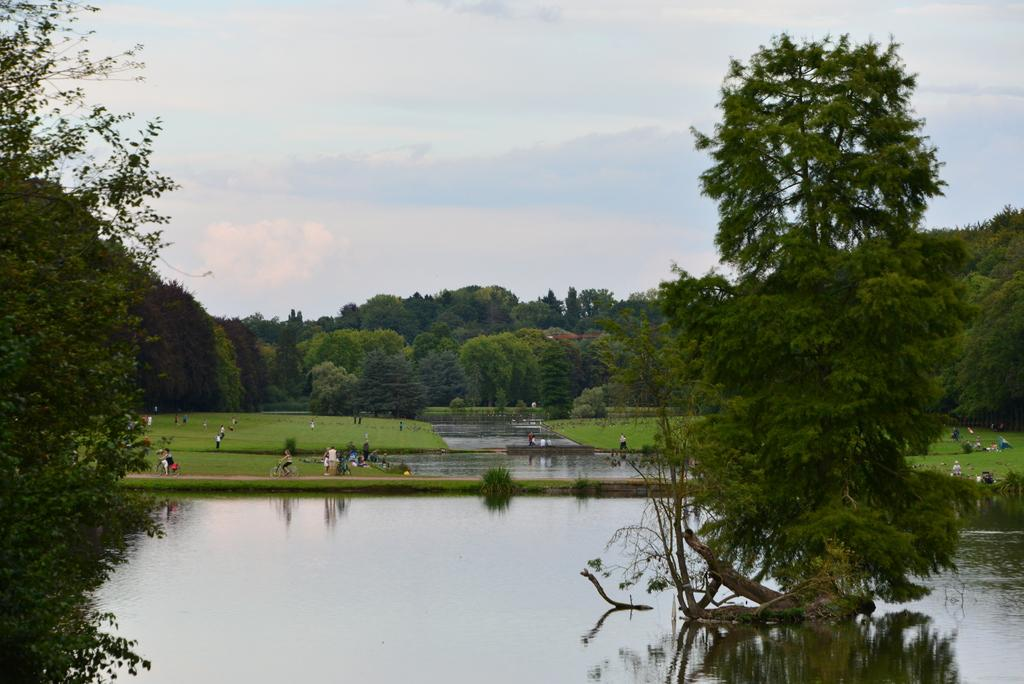What is one of the natural elements visible in the image? Water is visible in the image. What type of vegetation can be seen in the image? There are trees in the image. Who or what is present in the image? There are persons in the image. What type of ground cover is visible in the image? There is grass in the image. What is visible in the upper part of the image? The sky is visible in the image. What can be observed in the sky? Clouds are present in the sky. What type of skirt is being worn by the tree in the image? There are no skirts present in the image, as trees do not wear clothing. What color is the apparatus used by the clouds in the image? There is no apparatus associated with the clouds in the image; they are simply a natural atmospheric phenomenon. 